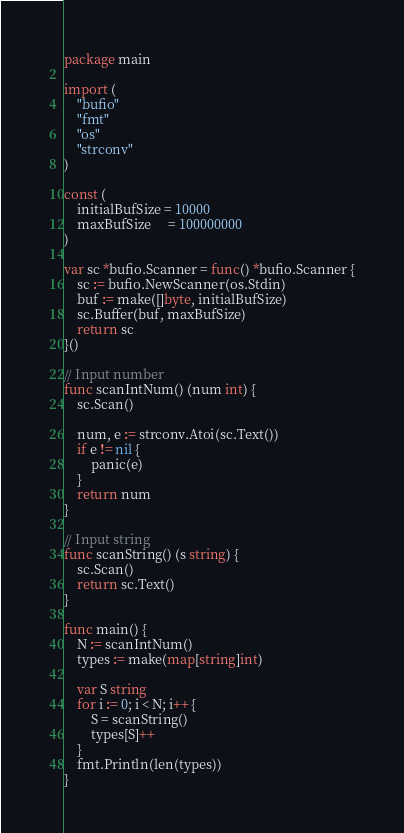Convert code to text. <code><loc_0><loc_0><loc_500><loc_500><_Go_>package main

import (
	"bufio"
	"fmt"
	"os"
	"strconv"
)

const (
	initialBufSize = 10000
	maxBufSize     = 100000000
)

var sc *bufio.Scanner = func() *bufio.Scanner {
	sc := bufio.NewScanner(os.Stdin)
	buf := make([]byte, initialBufSize)
	sc.Buffer(buf, maxBufSize)
	return sc
}()

// Input number
func scanIntNum() (num int) {
	sc.Scan()

	num, e := strconv.Atoi(sc.Text())
	if e != nil {
		panic(e)
	}
	return num
}

// Input string
func scanString() (s string) {
	sc.Scan()
	return sc.Text()
}

func main() {
	N := scanIntNum()
	types := make(map[string]int)

	var S string
	for i := 0; i < N; i++ {
		S = scanString()
		types[S]++
	}
	fmt.Println(len(types))
}
</code> 